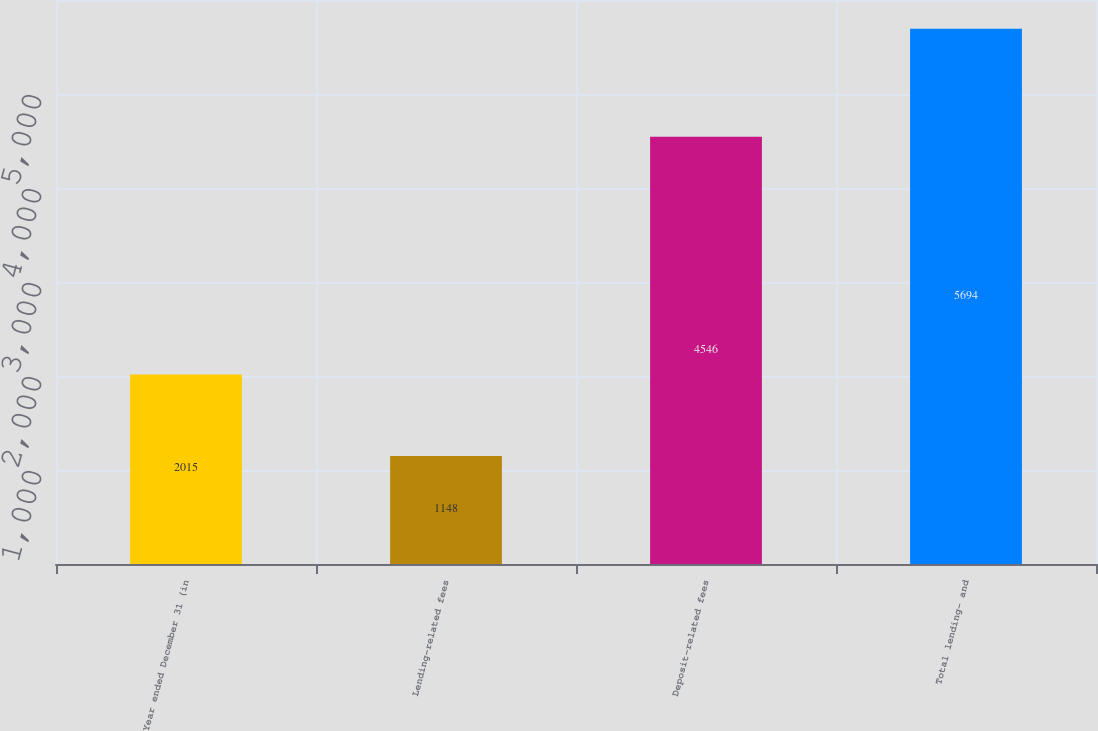Convert chart to OTSL. <chart><loc_0><loc_0><loc_500><loc_500><bar_chart><fcel>Year ended December 31 (in<fcel>Lending-related fees<fcel>Deposit-related fees<fcel>Total lending- and<nl><fcel>2015<fcel>1148<fcel>4546<fcel>5694<nl></chart> 